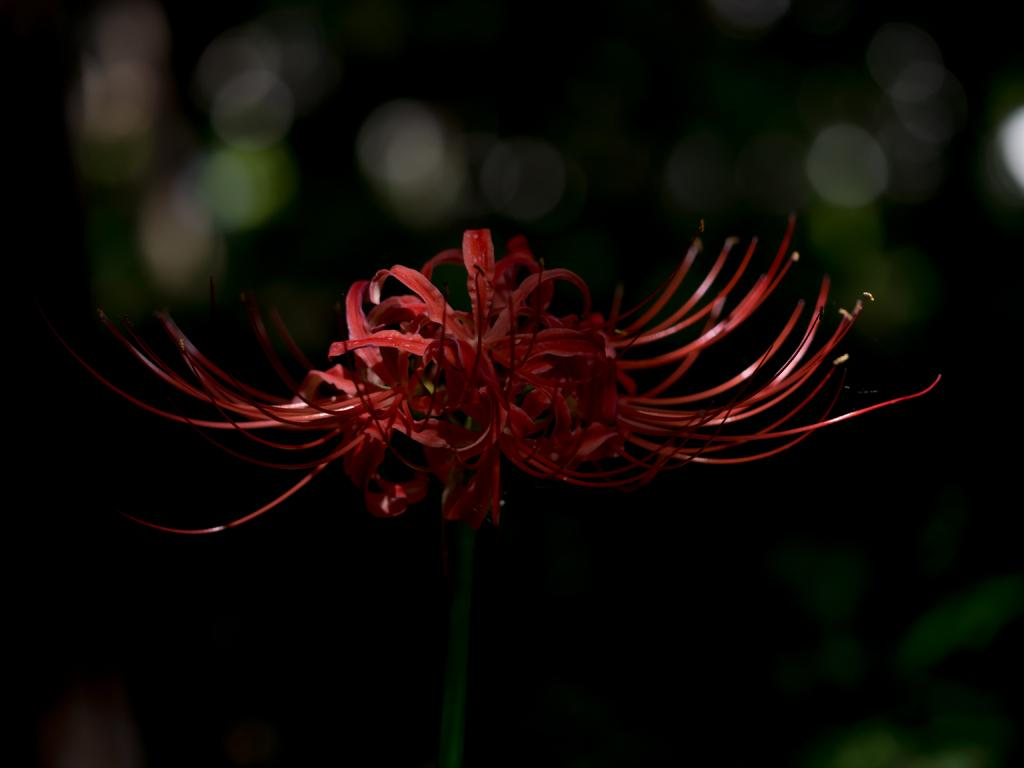What is the main subject of the image? There is a flower in the image. What color are the petals of the flower? The flower has red color petals. Is the flower attached to anything? Yes, the flower is present on the stem. How many boats can be seen sailing in the image? There are no boats present in the image; it features a flower with red petals on a stem. What is the flower's desire in the image? The flower is an inanimate object and does not have desires. 